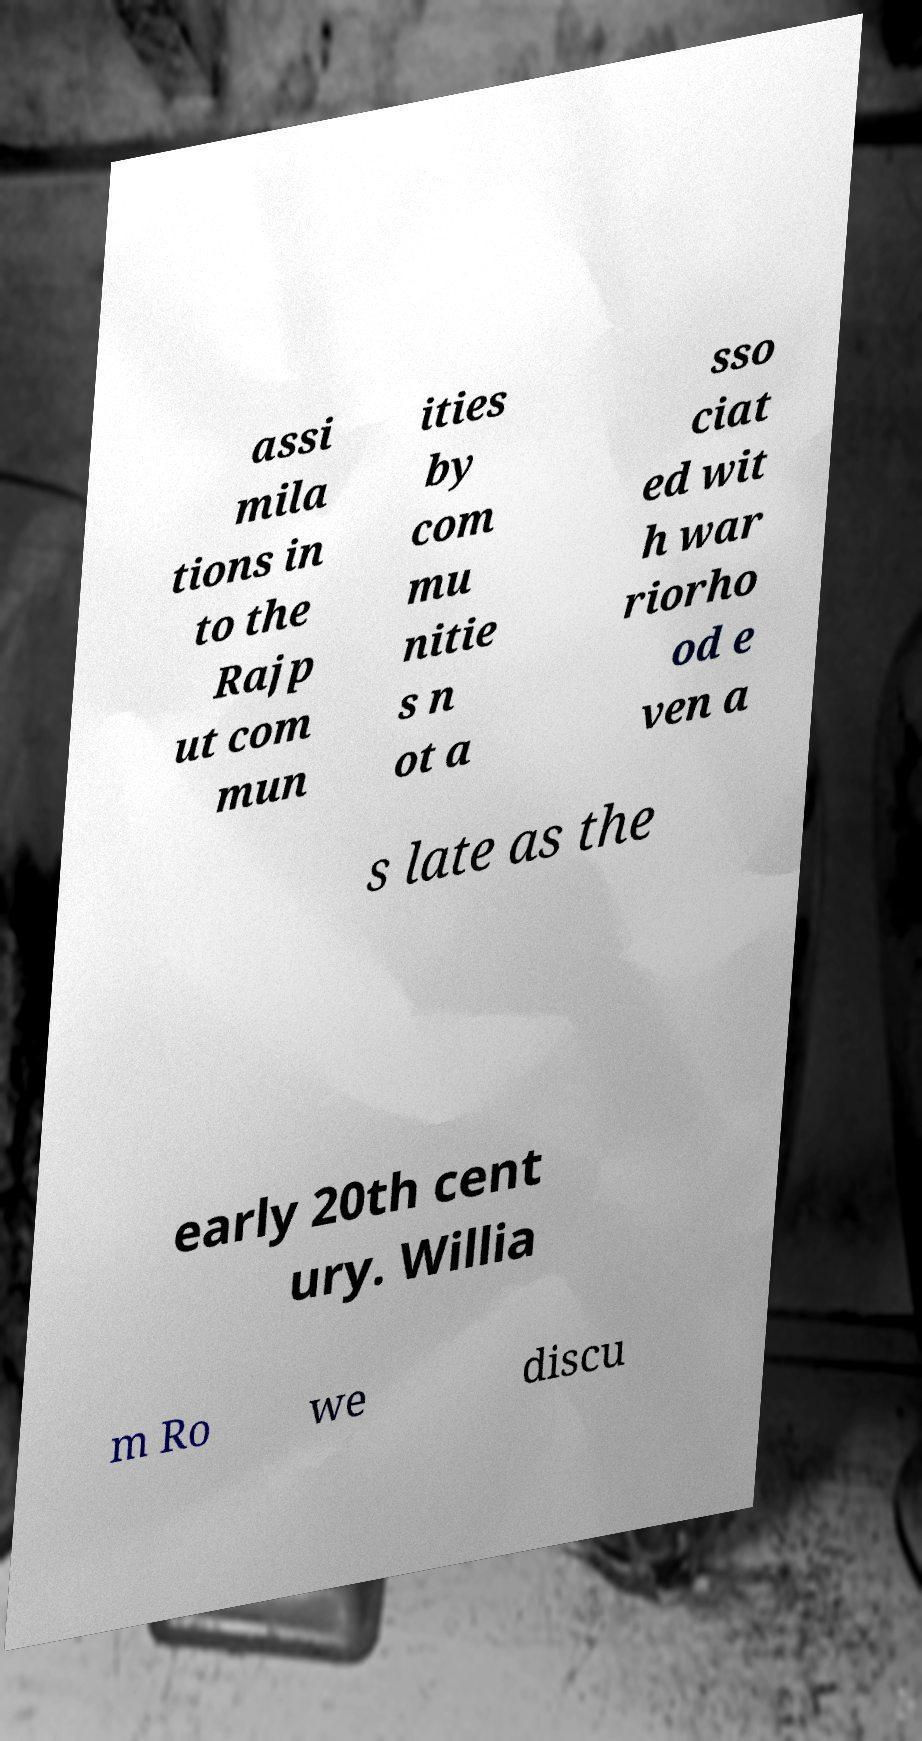Can you accurately transcribe the text from the provided image for me? assi mila tions in to the Rajp ut com mun ities by com mu nitie s n ot a sso ciat ed wit h war riorho od e ven a s late as the early 20th cent ury. Willia m Ro we discu 